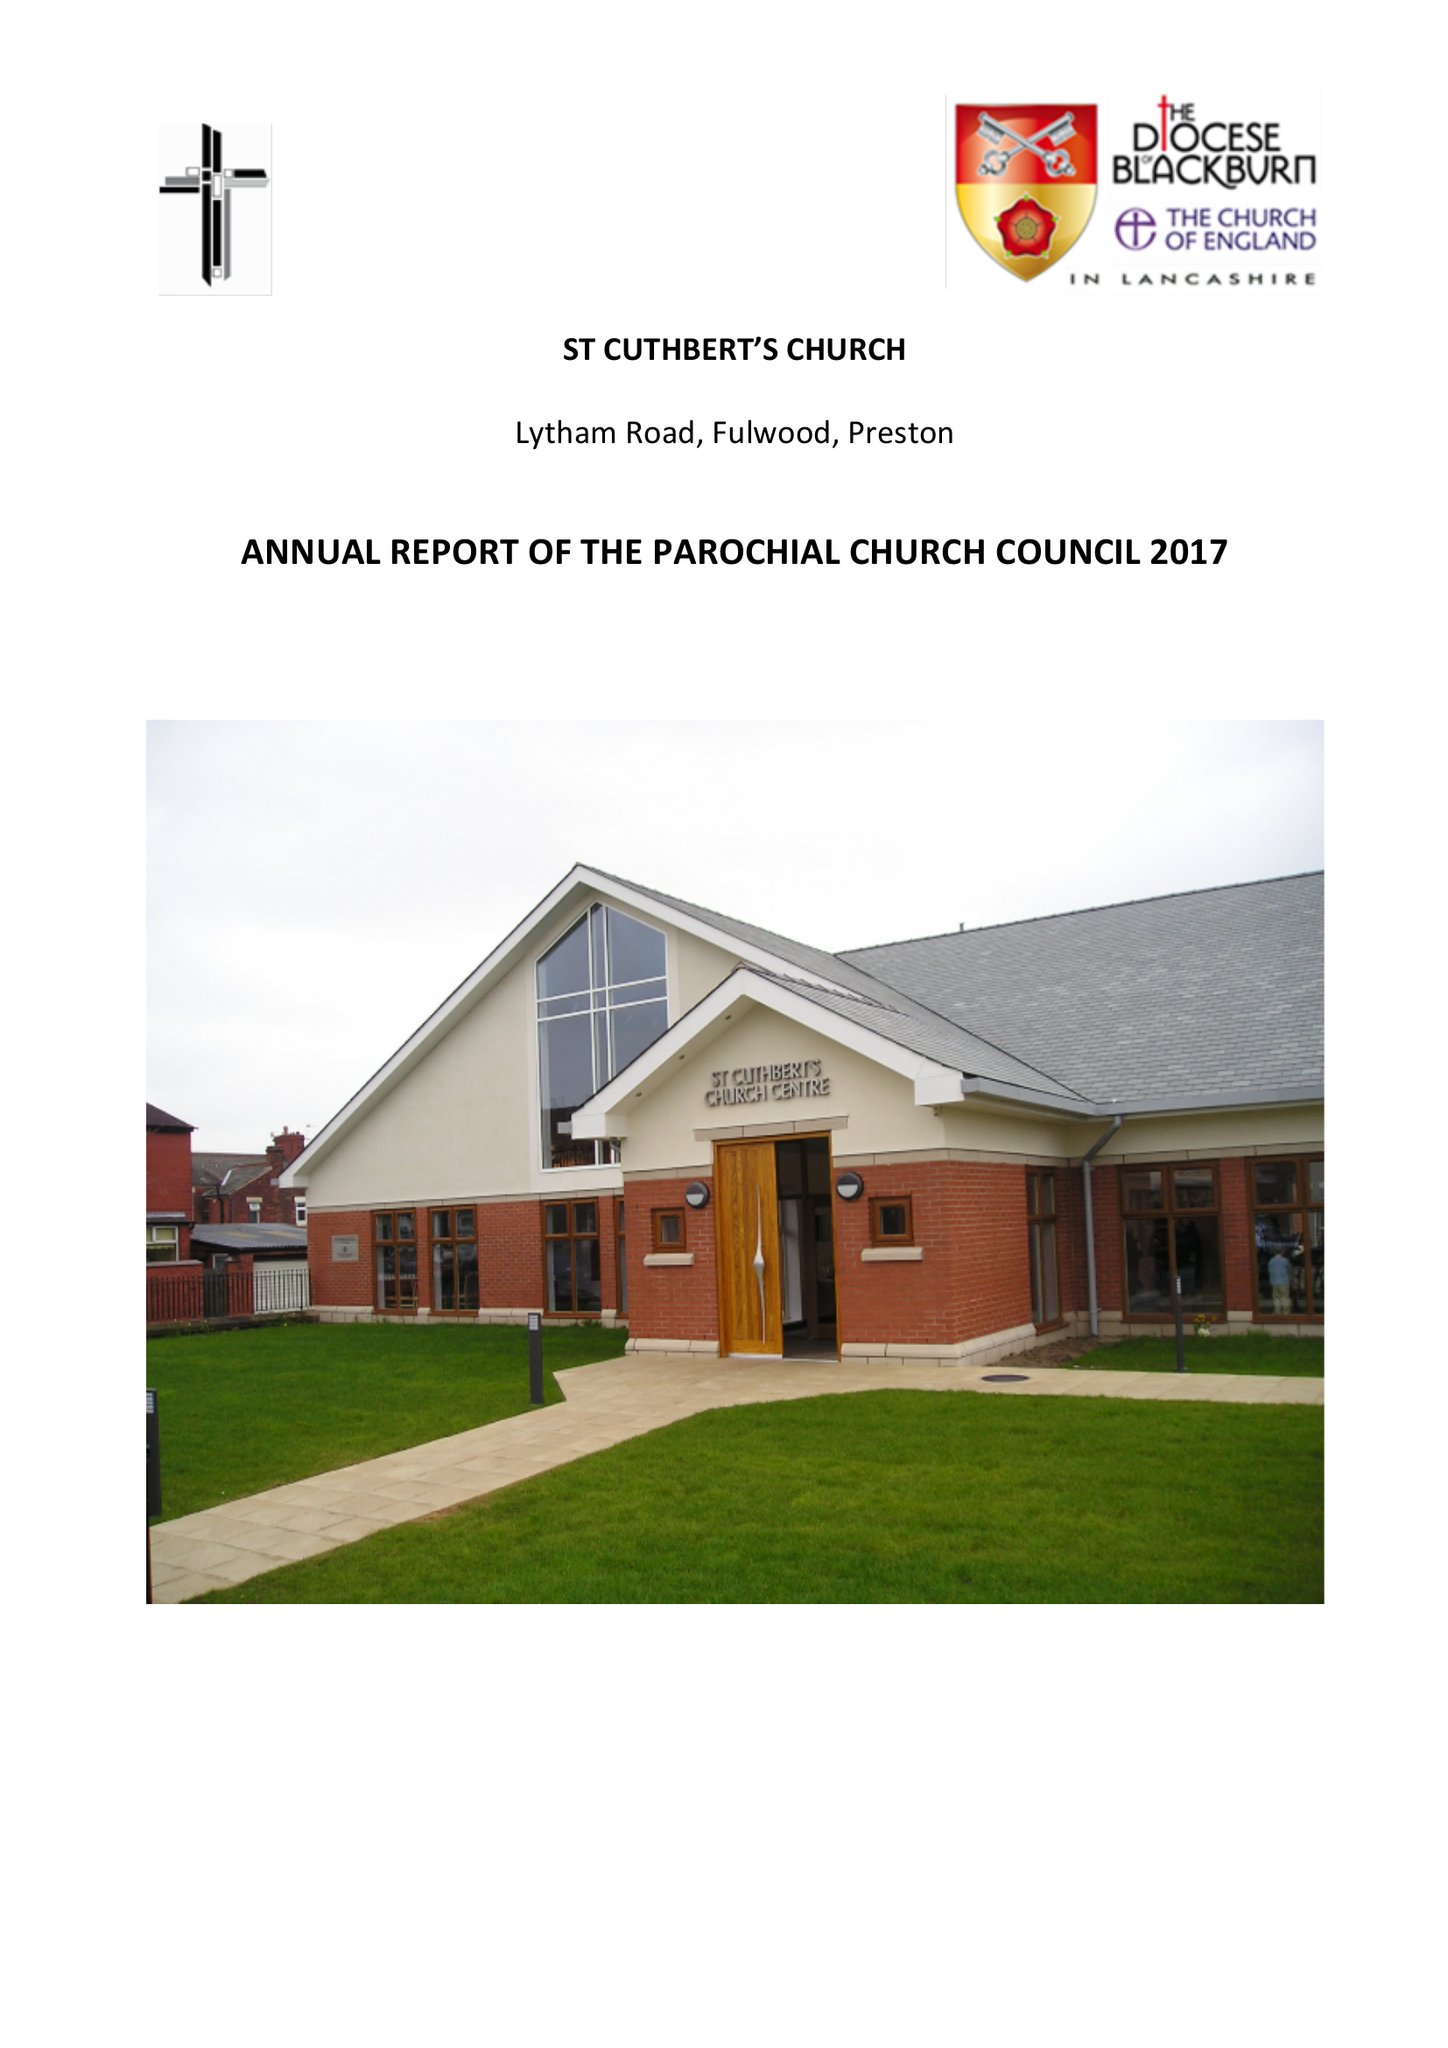What is the value for the income_annually_in_british_pounds?
Answer the question using a single word or phrase. 150936.02 